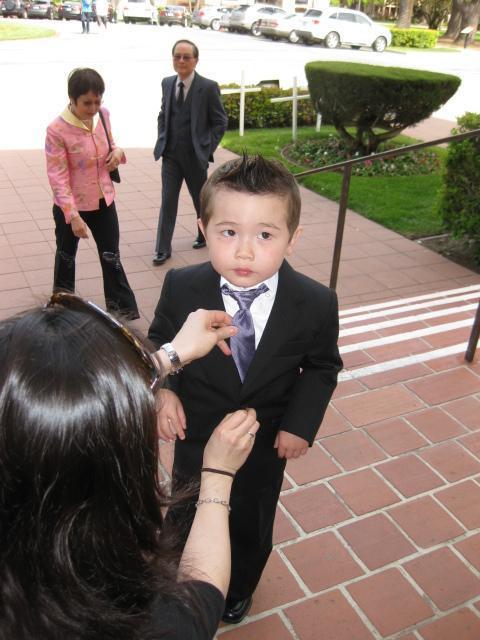How many people are in the photo?
Give a very brief answer. 4. 